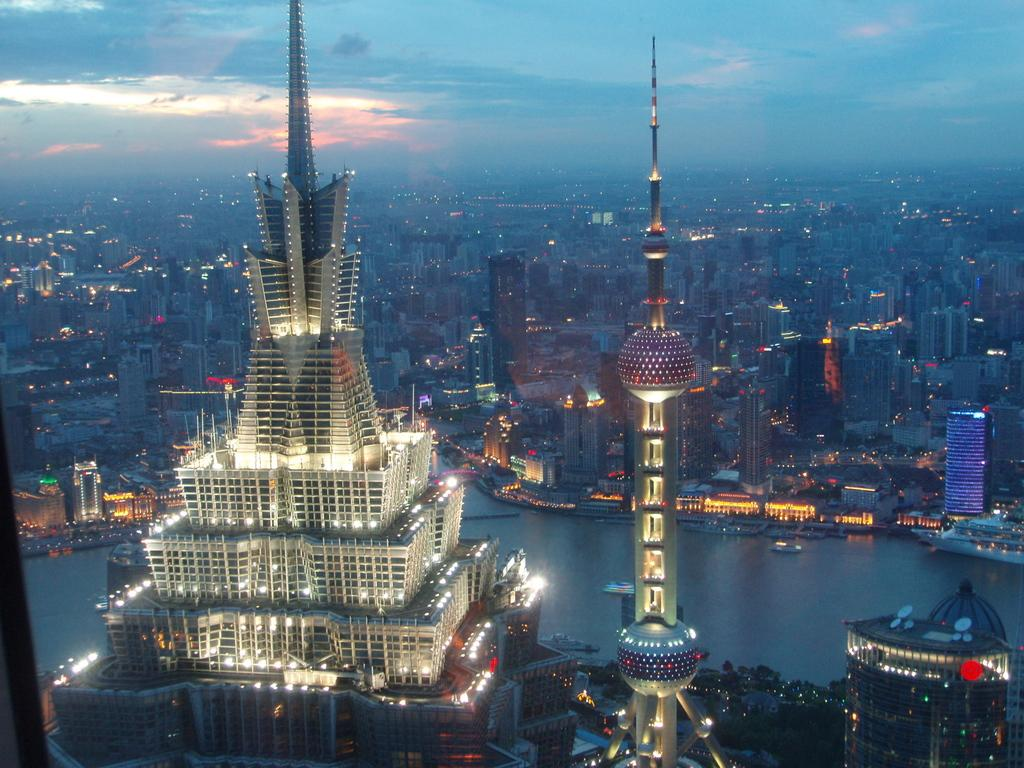What type of structures can be seen in the image? There are buildings in the image. What else is visible in the image besides the buildings? There are lights and trees visible in the image. What can be seen in the background of the image? The sky is visible in the background of the image. Where is the sister selling her handmade stitches at the market in the image? There is no market, sister, or handmade stitches present in the image. 